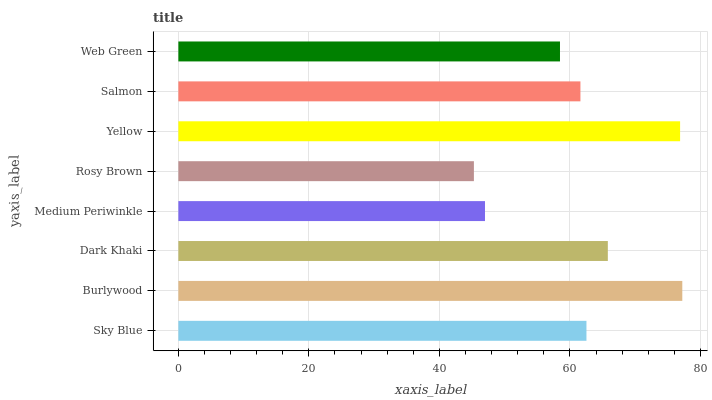Is Rosy Brown the minimum?
Answer yes or no. Yes. Is Burlywood the maximum?
Answer yes or no. Yes. Is Dark Khaki the minimum?
Answer yes or no. No. Is Dark Khaki the maximum?
Answer yes or no. No. Is Burlywood greater than Dark Khaki?
Answer yes or no. Yes. Is Dark Khaki less than Burlywood?
Answer yes or no. Yes. Is Dark Khaki greater than Burlywood?
Answer yes or no. No. Is Burlywood less than Dark Khaki?
Answer yes or no. No. Is Sky Blue the high median?
Answer yes or no. Yes. Is Salmon the low median?
Answer yes or no. Yes. Is Salmon the high median?
Answer yes or no. No. Is Medium Periwinkle the low median?
Answer yes or no. No. 